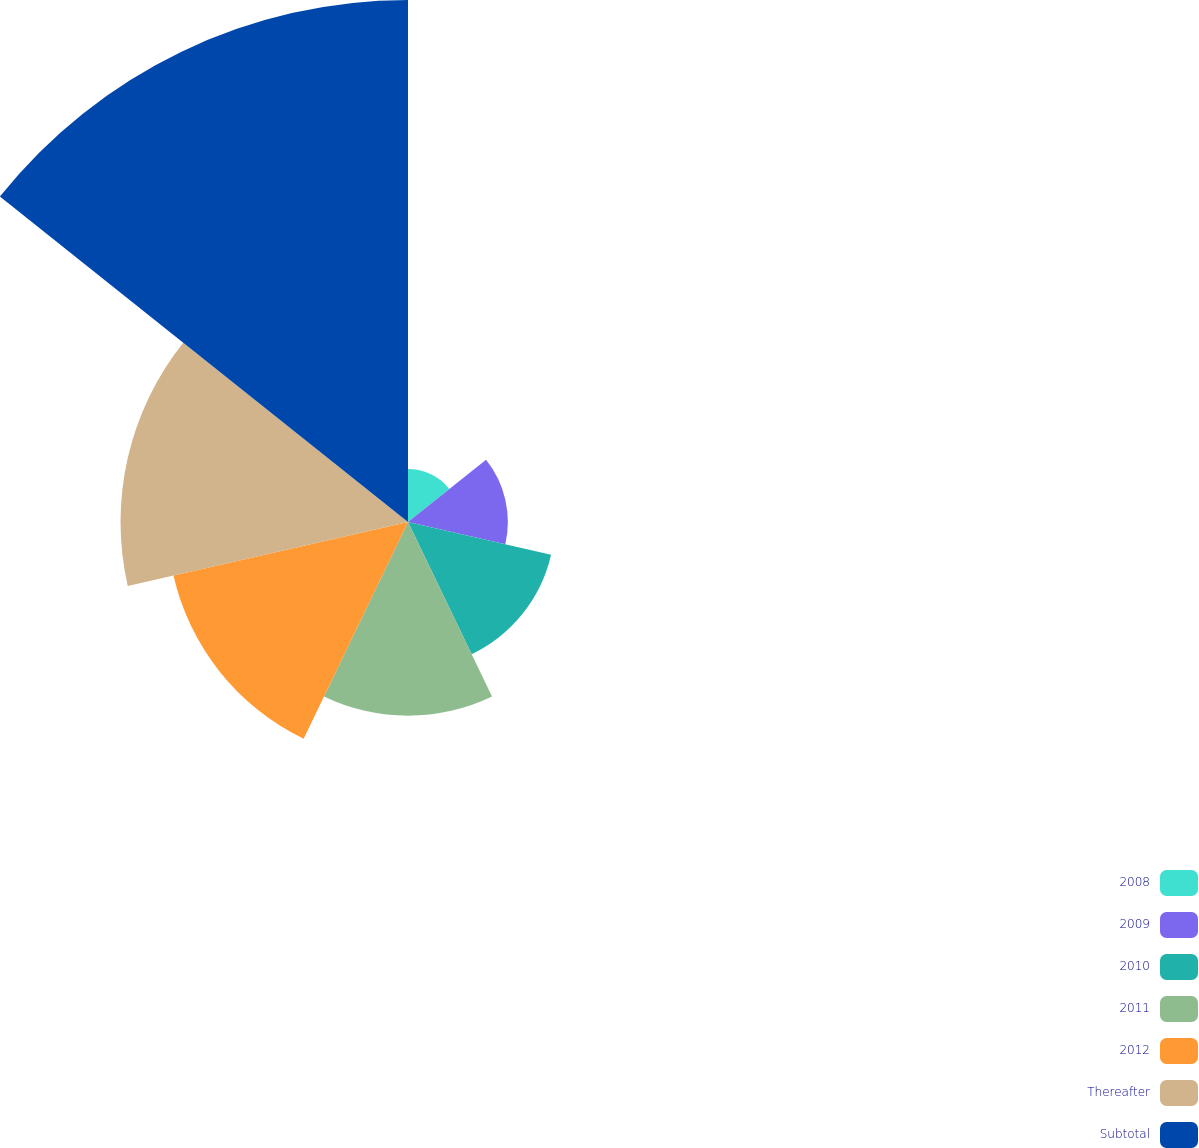Convert chart. <chart><loc_0><loc_0><loc_500><loc_500><pie_chart><fcel>2008<fcel>2009<fcel>2010<fcel>2011<fcel>2012<fcel>Thereafter<fcel>Subtotal<nl><fcel>3.43%<fcel>6.47%<fcel>9.51%<fcel>12.55%<fcel>15.59%<fcel>18.63%<fcel>33.83%<nl></chart> 